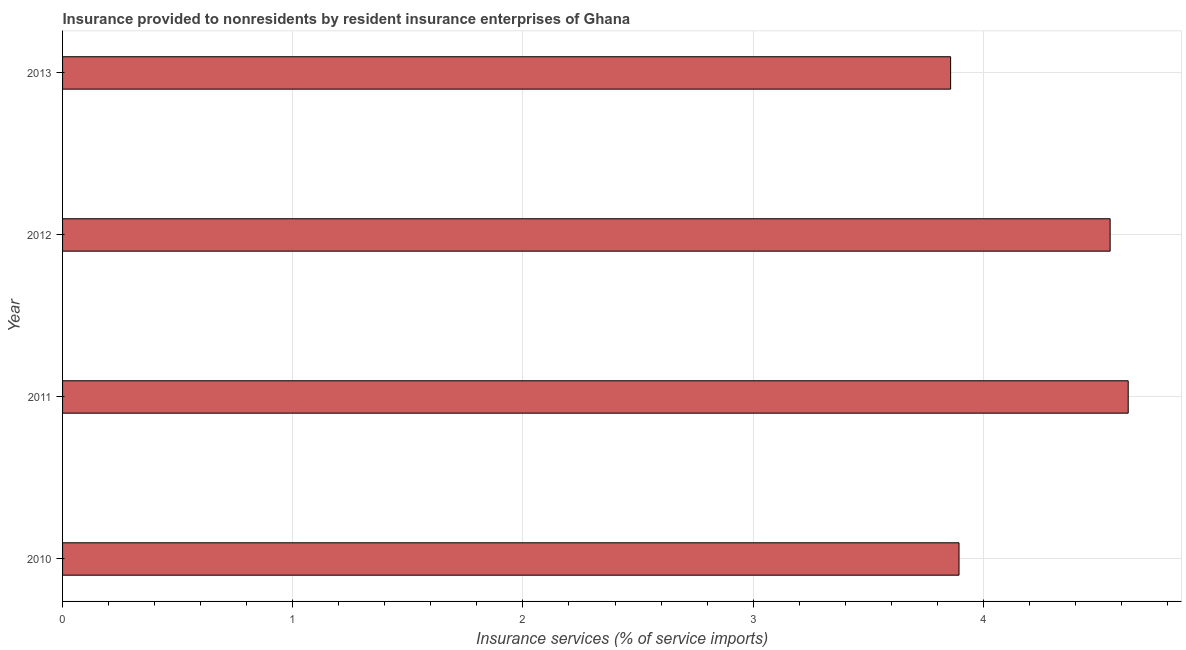Does the graph contain any zero values?
Offer a terse response. No. What is the title of the graph?
Provide a succinct answer. Insurance provided to nonresidents by resident insurance enterprises of Ghana. What is the label or title of the X-axis?
Provide a short and direct response. Insurance services (% of service imports). What is the label or title of the Y-axis?
Provide a short and direct response. Year. What is the insurance and financial services in 2011?
Make the answer very short. 4.63. Across all years, what is the maximum insurance and financial services?
Your response must be concise. 4.63. Across all years, what is the minimum insurance and financial services?
Offer a very short reply. 3.86. In which year was the insurance and financial services maximum?
Your answer should be very brief. 2011. What is the sum of the insurance and financial services?
Offer a very short reply. 16.93. What is the difference between the insurance and financial services in 2011 and 2012?
Your answer should be compact. 0.08. What is the average insurance and financial services per year?
Ensure brevity in your answer.  4.23. What is the median insurance and financial services?
Offer a very short reply. 4.22. Do a majority of the years between 2010 and 2012 (inclusive) have insurance and financial services greater than 3.2 %?
Your answer should be very brief. Yes. Is the insurance and financial services in 2011 less than that in 2012?
Ensure brevity in your answer.  No. Is the difference between the insurance and financial services in 2010 and 2011 greater than the difference between any two years?
Ensure brevity in your answer.  No. What is the difference between the highest and the second highest insurance and financial services?
Make the answer very short. 0.08. Is the sum of the insurance and financial services in 2010 and 2011 greater than the maximum insurance and financial services across all years?
Provide a short and direct response. Yes. What is the difference between the highest and the lowest insurance and financial services?
Offer a terse response. 0.77. In how many years, is the insurance and financial services greater than the average insurance and financial services taken over all years?
Offer a terse response. 2. How many years are there in the graph?
Provide a succinct answer. 4. Are the values on the major ticks of X-axis written in scientific E-notation?
Offer a very short reply. No. What is the Insurance services (% of service imports) in 2010?
Your answer should be compact. 3.89. What is the Insurance services (% of service imports) in 2011?
Give a very brief answer. 4.63. What is the Insurance services (% of service imports) of 2012?
Keep it short and to the point. 4.55. What is the Insurance services (% of service imports) in 2013?
Provide a short and direct response. 3.86. What is the difference between the Insurance services (% of service imports) in 2010 and 2011?
Provide a succinct answer. -0.74. What is the difference between the Insurance services (% of service imports) in 2010 and 2012?
Keep it short and to the point. -0.66. What is the difference between the Insurance services (% of service imports) in 2010 and 2013?
Your answer should be compact. 0.04. What is the difference between the Insurance services (% of service imports) in 2011 and 2012?
Ensure brevity in your answer.  0.08. What is the difference between the Insurance services (% of service imports) in 2011 and 2013?
Offer a very short reply. 0.77. What is the difference between the Insurance services (% of service imports) in 2012 and 2013?
Keep it short and to the point. 0.69. What is the ratio of the Insurance services (% of service imports) in 2010 to that in 2011?
Your answer should be very brief. 0.84. What is the ratio of the Insurance services (% of service imports) in 2010 to that in 2012?
Offer a very short reply. 0.86. What is the ratio of the Insurance services (% of service imports) in 2010 to that in 2013?
Provide a succinct answer. 1.01. What is the ratio of the Insurance services (% of service imports) in 2012 to that in 2013?
Offer a terse response. 1.18. 